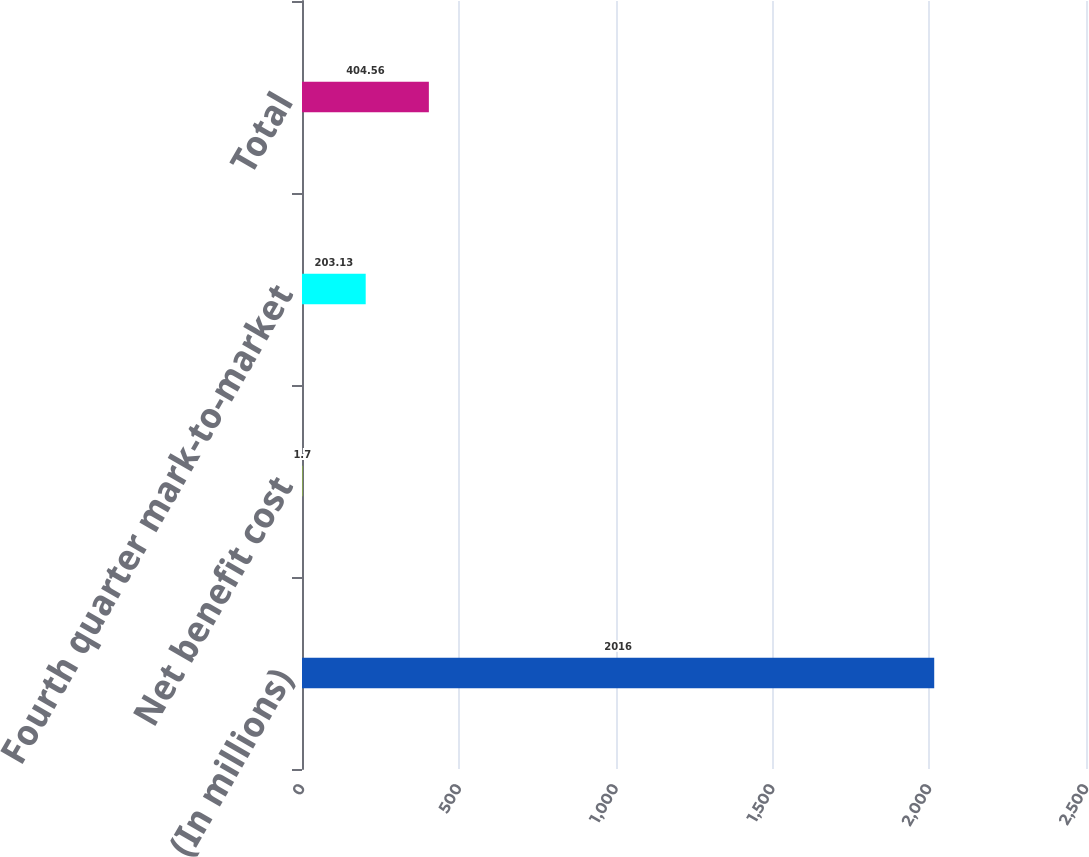<chart> <loc_0><loc_0><loc_500><loc_500><bar_chart><fcel>(In millions)<fcel>Net benefit cost<fcel>Fourth quarter mark-to-market<fcel>Total<nl><fcel>2016<fcel>1.7<fcel>203.13<fcel>404.56<nl></chart> 